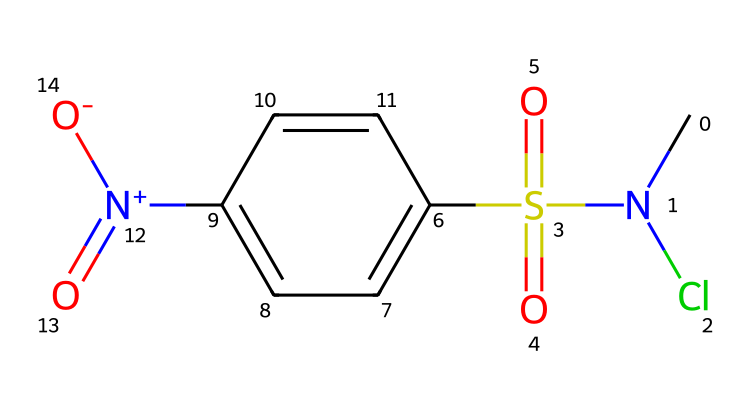What is the main functional group present in this compound? The compound contains the sulfonamide group, which is identified by the presence of the sulfonyl (S(=O)(=O)) portion linked to a nitrogen atom (N).
Answer: sulfonamide How many chlorine atoms are present in this structure? By examining the SMILES, there's one 'Cl' indicating the presence of a single chlorine atom in the structure.
Answer: one What type of chemical is this primarily considered? The presence of the nitro group ([N+](=O)[O-]) and sulfonyl group indicates that this compound is classified as an aryl sulfonamide with photoreactive properties.
Answer: aryl sulfonamide What is the total number of nitrogen atoms in this molecule? In the SMILES, there are two nitrogen atoms, one in the sulfonamide part (CN) and one in the nitro group ([N+]).
Answer: two What kind of preservation effect might this compound have on museum artifacts? The photoreactive nature and potential antimicrobial properties of chlorine-based compounds can help prevent deterioration and microbial growth on artifacts.
Answer: preservation What does the presence of the nitro group suggest about the reactivity of this chemical? The nitro group typically increases the reactivity due to its electron-withdrawing nature, suggesting that this compound may react readily under light exposure.
Answer: increased reactivity 